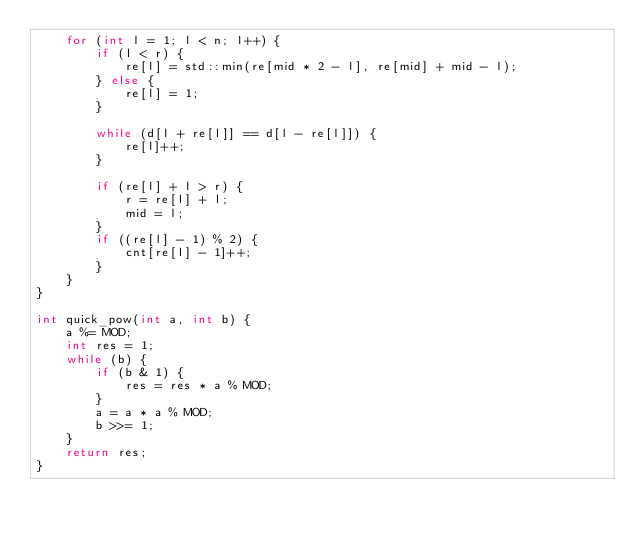<code> <loc_0><loc_0><loc_500><loc_500><_C++_>    for (int l = 1; l < n; l++) {
        if (l < r) {
            re[l] = std::min(re[mid * 2 - l], re[mid] + mid - l);
        } else {
            re[l] = 1;
        }

        while (d[l + re[l]] == d[l - re[l]]) {
            re[l]++;
        }

        if (re[l] + l > r) {
            r = re[l] + l;
            mid = l;
        }
        if ((re[l] - 1) % 2) {
            cnt[re[l] - 1]++;
        }
    }
}

int quick_pow(int a, int b) {
    a %= MOD;
    int res = 1;
    while (b) {
        if (b & 1) {
            res = res * a % MOD;
        }
        a = a * a % MOD;
        b >>= 1;
    }
    return res;
}</code> 